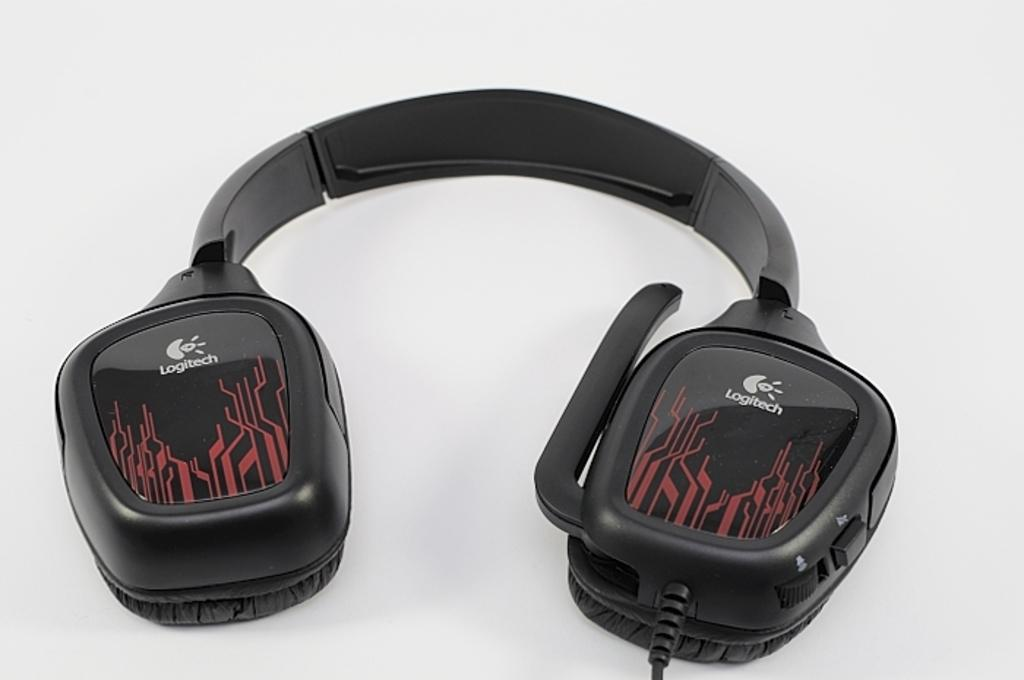<image>
Give a short and clear explanation of the subsequent image. Some Logitech headphones are sitting on a white surface. 